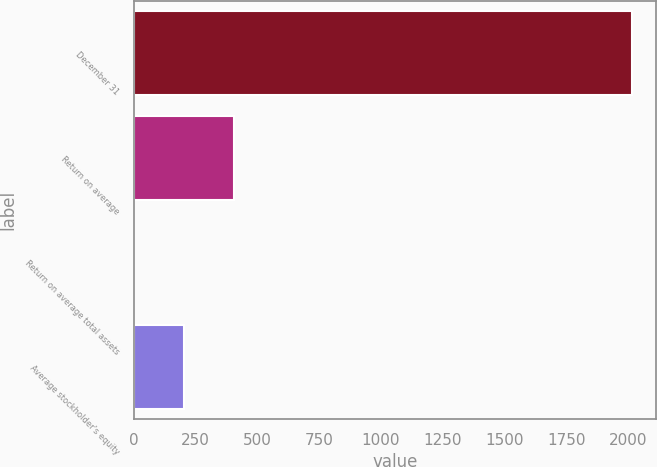<chart> <loc_0><loc_0><loc_500><loc_500><bar_chart><fcel>December 31<fcel>Return on average<fcel>Return on average total assets<fcel>Average stockholder's equity<nl><fcel>2015<fcel>403.71<fcel>0.89<fcel>202.3<nl></chart> 